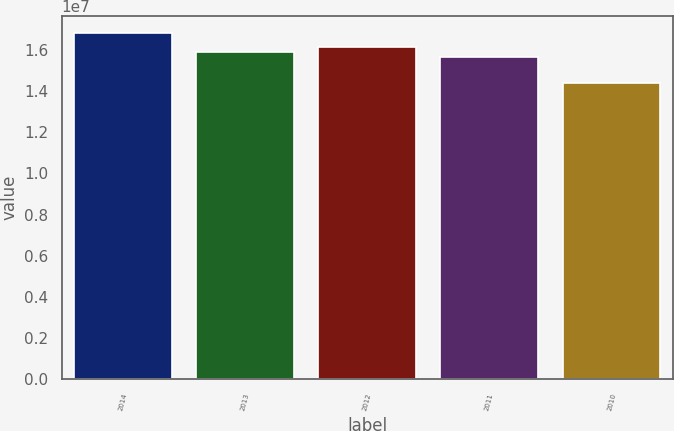<chart> <loc_0><loc_0><loc_500><loc_500><bar_chart><fcel>2014<fcel>2013<fcel>2012<fcel>2011<fcel>2010<nl><fcel>1.6808e+07<fcel>1.59035e+07<fcel>1.6143e+07<fcel>1.5664e+07<fcel>1.4413e+07<nl></chart> 